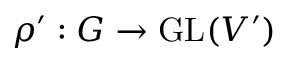Convert formula to latex. <formula><loc_0><loc_0><loc_500><loc_500>\rho ^ { \prime } \colon G \to { G L } ( V ^ { \prime } )</formula> 